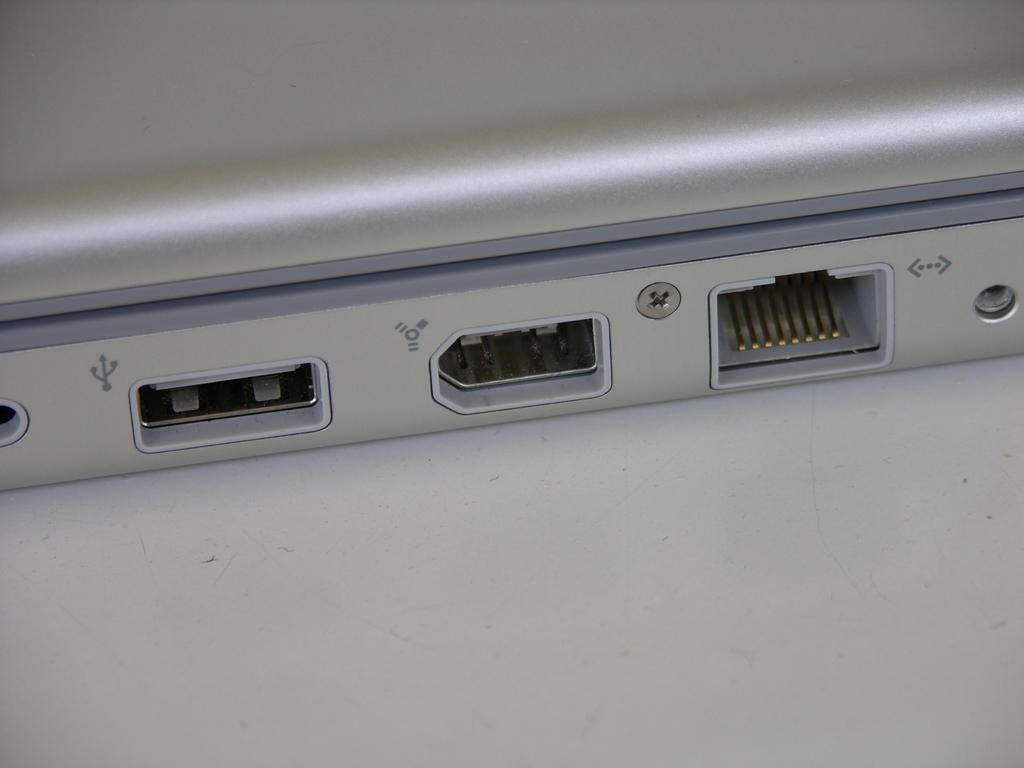Please provide a concise description of this image. There are ports of an electronic device in the image. 